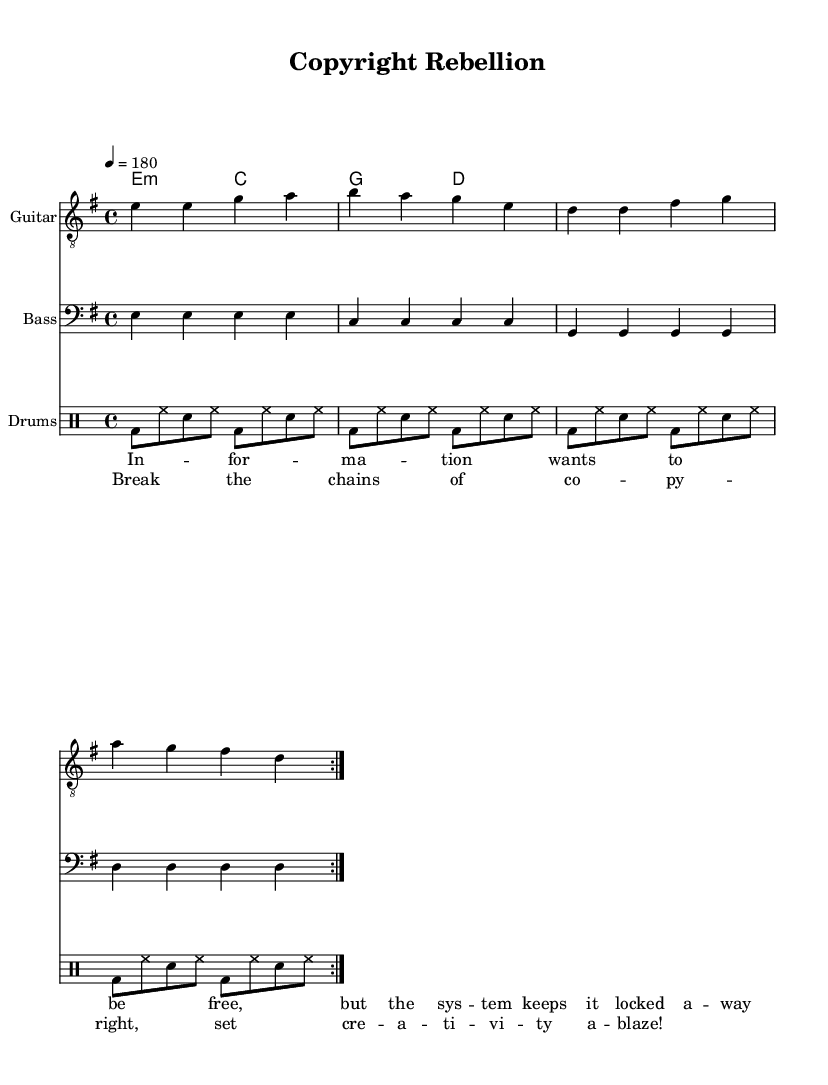What is the key signature of this music? The key signature is E minor, which includes one sharp (F#) and indicates the related scale.
Answer: E minor What is the time signature of this music? The time signature shown at the beginning of the score is 4/4, indicating that there are four beats per measure.
Answer: 4/4 What is the tempo marking of this music? The tempo marking indicates that the music should be played at a speed of 180 beats per minute.
Answer: 180 How many times is the main musical motif repeated in the guitar part? The guitar music includes a repeat sign which indicates that the main motif is played two times.
Answer: Two times What is the main theme reflected in the lyrics? The lyrics discuss the theme of freedom in relation to information and creativity, aligning with anti-establishment sentiments.
Answer: Freedom What type of song structure is commonly found in punk anthems like this one? The structure typically follows a verse-chorus pattern, which emphasizes the message in a straightforward manner.
Answer: Verse-chorus How does the drum pattern contribute to the punk style of this song? The drum pattern uses consistent bass and snare hits, creating a driving and aggressive rhythm characteristic of punk music.
Answer: Driving rhythm 